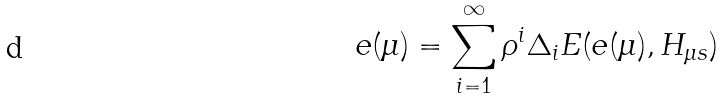Convert formula to latex. <formula><loc_0><loc_0><loc_500><loc_500>e ( \mu ) = \sum _ { i = 1 } ^ { \infty } \rho ^ { i } \Delta _ { i } E ( e ( \mu ) , H _ { \mu s } )</formula> 